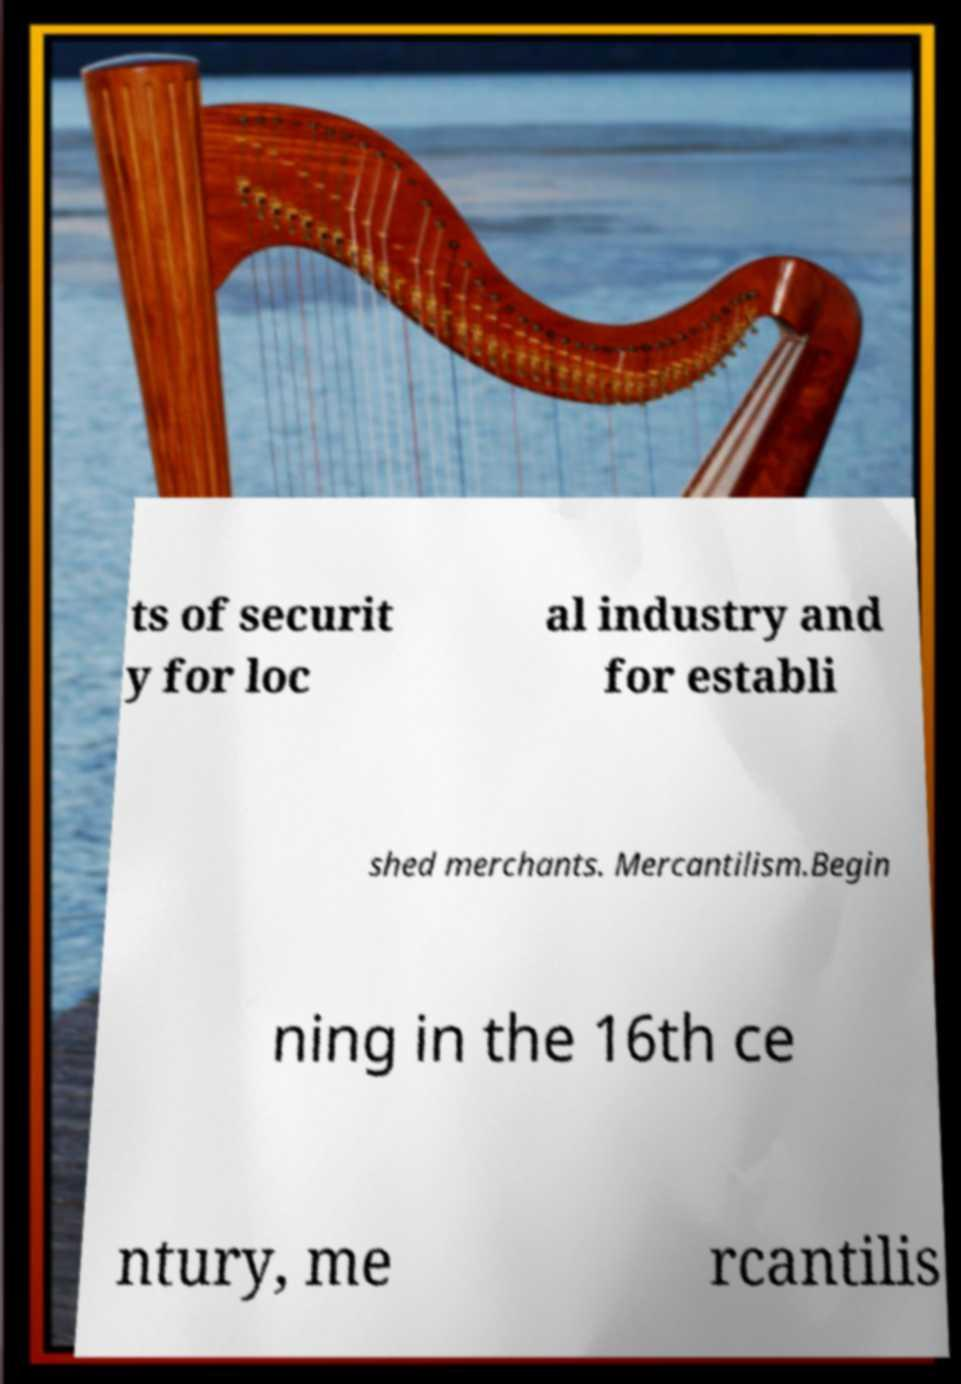There's text embedded in this image that I need extracted. Can you transcribe it verbatim? ts of securit y for loc al industry and for establi shed merchants. Mercantilism.Begin ning in the 16th ce ntury, me rcantilis 